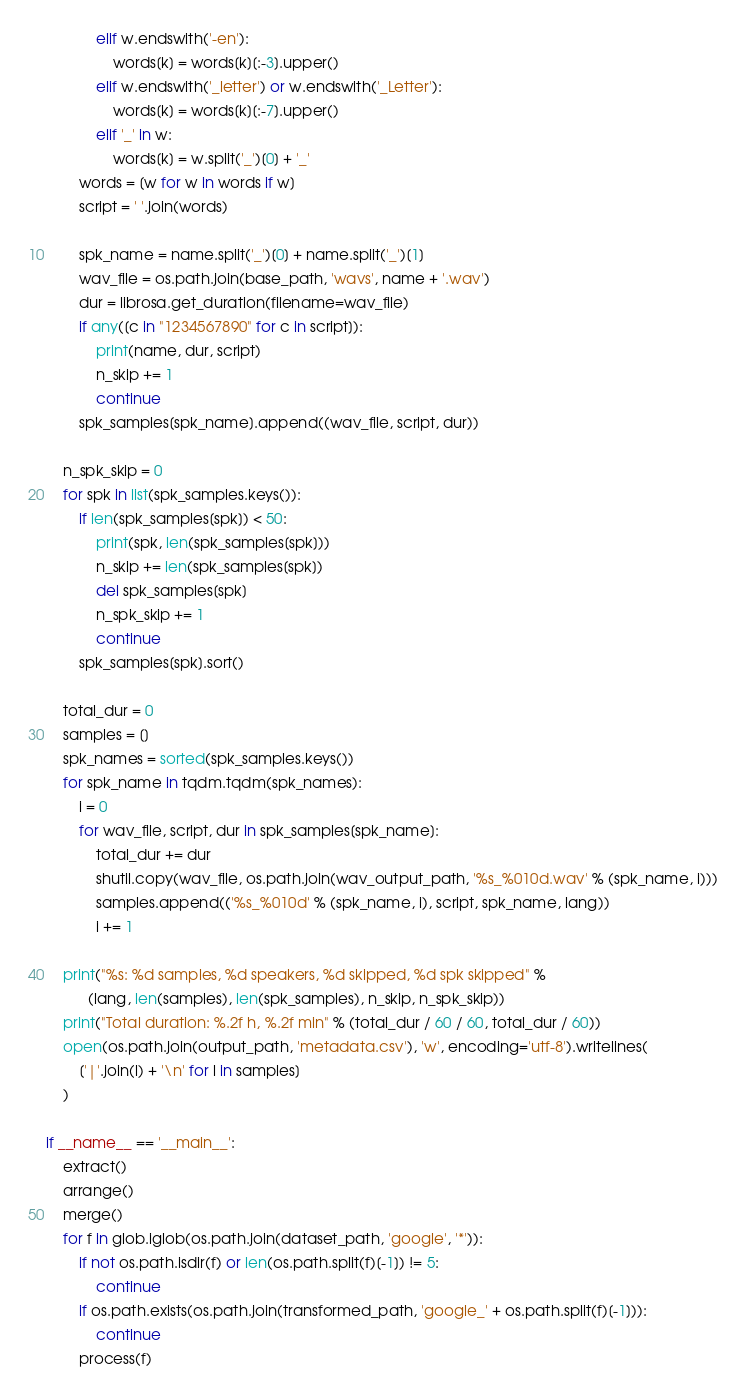Convert code to text. <code><loc_0><loc_0><loc_500><loc_500><_Python_>            elif w.endswith('-en'):
                words[k] = words[k][:-3].upper()
            elif w.endswith('_letter') or w.endswith('_Letter'):
                words[k] = words[k][:-7].upper()
            elif '_' in w:
                words[k] = w.split('_')[0] + '_'
        words = [w for w in words if w]
        script = ' '.join(words)

        spk_name = name.split('_')[0] + name.split('_')[1]
        wav_file = os.path.join(base_path, 'wavs', name + '.wav')
        dur = librosa.get_duration(filename=wav_file)
        if any([c in "1234567890" for c in script]):
            print(name, dur, script)
            n_skip += 1
            continue
        spk_samples[spk_name].append((wav_file, script, dur))

    n_spk_skip = 0
    for spk in list(spk_samples.keys()):
        if len(spk_samples[spk]) < 50:
            print(spk, len(spk_samples[spk]))
            n_skip += len(spk_samples[spk])
            del spk_samples[spk]
            n_spk_skip += 1
            continue
        spk_samples[spk].sort()

    total_dur = 0
    samples = []
    spk_names = sorted(spk_samples.keys())
    for spk_name in tqdm.tqdm(spk_names):
        i = 0
        for wav_file, script, dur in spk_samples[spk_name]:
            total_dur += dur
            shutil.copy(wav_file, os.path.join(wav_output_path, '%s_%010d.wav' % (spk_name, i)))
            samples.append(('%s_%010d' % (spk_name, i), script, spk_name, lang))
            i += 1

    print("%s: %d samples, %d speakers, %d skipped, %d spk skipped" %
          (lang, len(samples), len(spk_samples), n_skip, n_spk_skip))
    print("Total duration: %.2f h, %.2f min" % (total_dur / 60 / 60, total_dur / 60))
    open(os.path.join(output_path, 'metadata.csv'), 'w', encoding='utf-8').writelines(
        ['|'.join(l) + '\n' for l in samples]
    )

if __name__ == '__main__':
    extract()
    arrange()
    merge()
    for f in glob.iglob(os.path.join(dataset_path, 'google', '*')):
        if not os.path.isdir(f) or len(os.path.split(f)[-1]) != 5:
            continue
        if os.path.exists(os.path.join(transformed_path, 'google_' + os.path.split(f)[-1])):
            continue
        process(f)</code> 